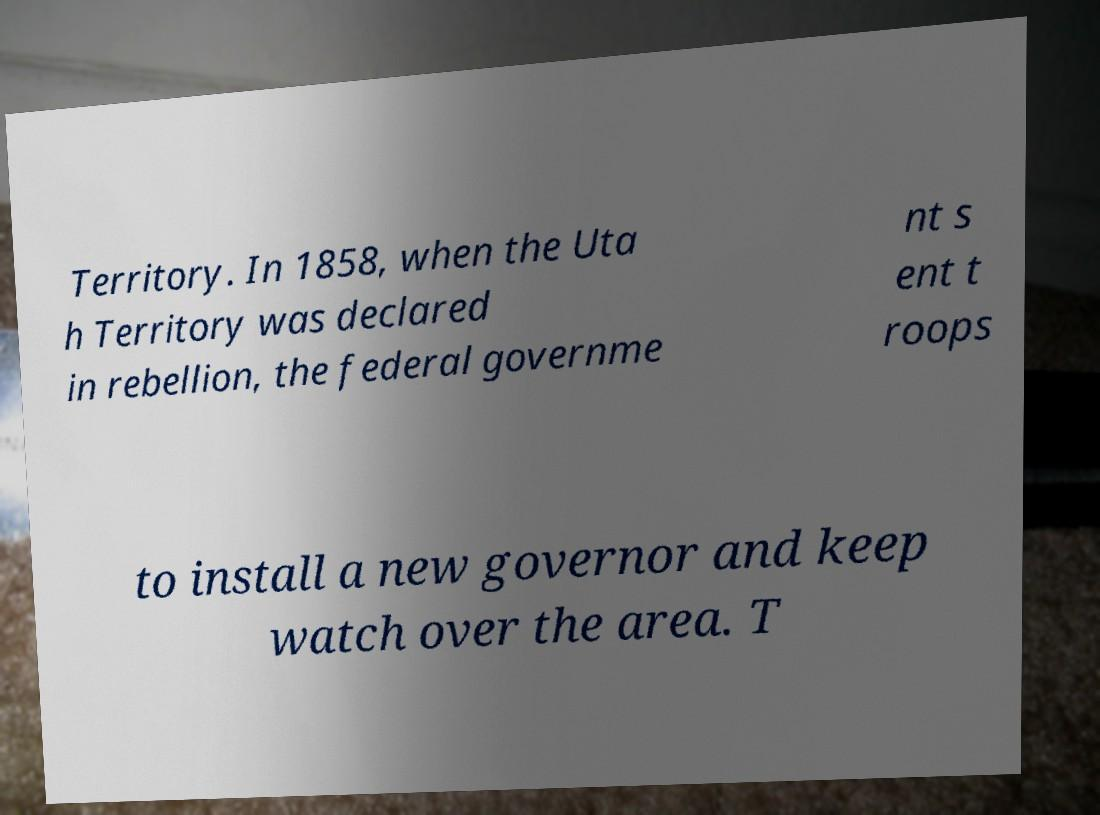Please identify and transcribe the text found in this image. Territory. In 1858, when the Uta h Territory was declared in rebellion, the federal governme nt s ent t roops to install a new governor and keep watch over the area. T 